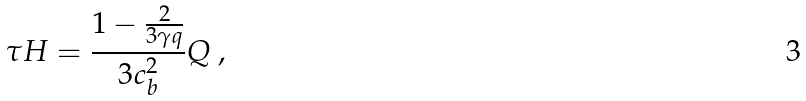<formula> <loc_0><loc_0><loc_500><loc_500>\tau H = \frac { 1 - \frac { 2 } { 3 \gamma q } } { 3 c _ { b } ^ { 2 } } Q \ ,</formula> 